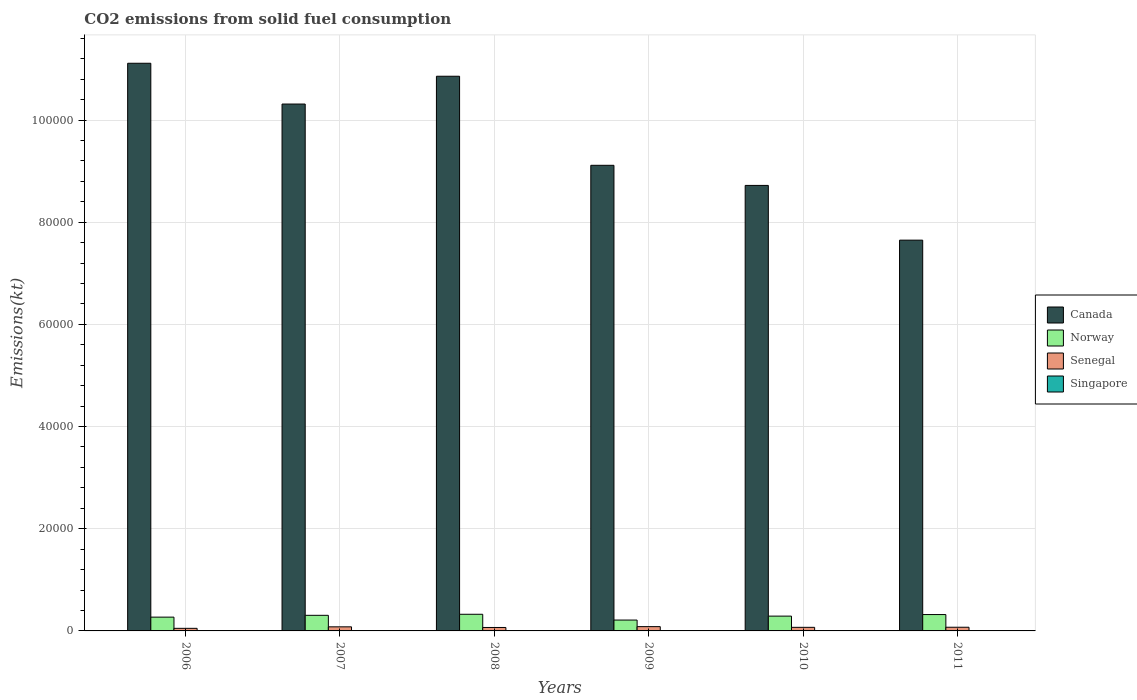How many groups of bars are there?
Offer a terse response. 6. What is the label of the 4th group of bars from the left?
Ensure brevity in your answer.  2009. What is the amount of CO2 emitted in Canada in 2010?
Your answer should be compact. 8.72e+04. Across all years, what is the maximum amount of CO2 emitted in Norway?
Your response must be concise. 3259.96. Across all years, what is the minimum amount of CO2 emitted in Senegal?
Make the answer very short. 506.05. In which year was the amount of CO2 emitted in Canada maximum?
Provide a short and direct response. 2006. In which year was the amount of CO2 emitted in Canada minimum?
Give a very brief answer. 2011. What is the total amount of CO2 emitted in Singapore in the graph?
Your answer should be very brief. 113.68. What is the difference between the amount of CO2 emitted in Norway in 2008 and that in 2010?
Provide a short and direct response. 363.03. What is the difference between the amount of CO2 emitted in Canada in 2007 and the amount of CO2 emitted in Singapore in 2009?
Your response must be concise. 1.03e+05. What is the average amount of CO2 emitted in Singapore per year?
Ensure brevity in your answer.  18.95. In the year 2008, what is the difference between the amount of CO2 emitted in Norway and amount of CO2 emitted in Singapore?
Your response must be concise. 3241.63. In how many years, is the amount of CO2 emitted in Norway greater than 104000 kt?
Your answer should be very brief. 0. What is the ratio of the amount of CO2 emitted in Singapore in 2007 to that in 2011?
Offer a terse response. 1.75. Is the amount of CO2 emitted in Norway in 2007 less than that in 2008?
Your answer should be compact. Yes. What is the difference between the highest and the second highest amount of CO2 emitted in Norway?
Ensure brevity in your answer.  55.01. What is the difference between the highest and the lowest amount of CO2 emitted in Norway?
Ensure brevity in your answer.  1133.1. In how many years, is the amount of CO2 emitted in Singapore greater than the average amount of CO2 emitted in Singapore taken over all years?
Ensure brevity in your answer.  2. What does the 2nd bar from the left in 2008 represents?
Keep it short and to the point. Norway. What does the 1st bar from the right in 2009 represents?
Give a very brief answer. Singapore. Is it the case that in every year, the sum of the amount of CO2 emitted in Senegal and amount of CO2 emitted in Norway is greater than the amount of CO2 emitted in Canada?
Provide a succinct answer. No. How many bars are there?
Ensure brevity in your answer.  24. Are all the bars in the graph horizontal?
Give a very brief answer. No. What is the difference between two consecutive major ticks on the Y-axis?
Offer a very short reply. 2.00e+04. Does the graph contain any zero values?
Make the answer very short. No. Where does the legend appear in the graph?
Provide a short and direct response. Center right. How are the legend labels stacked?
Keep it short and to the point. Vertical. What is the title of the graph?
Your answer should be compact. CO2 emissions from solid fuel consumption. Does "Latvia" appear as one of the legend labels in the graph?
Give a very brief answer. No. What is the label or title of the X-axis?
Make the answer very short. Years. What is the label or title of the Y-axis?
Provide a short and direct response. Emissions(kt). What is the Emissions(kt) in Canada in 2006?
Make the answer very short. 1.11e+05. What is the Emissions(kt) of Norway in 2006?
Provide a succinct answer. 2698.91. What is the Emissions(kt) in Senegal in 2006?
Provide a short and direct response. 506.05. What is the Emissions(kt) of Singapore in 2006?
Provide a succinct answer. 14.67. What is the Emissions(kt) in Canada in 2007?
Make the answer very short. 1.03e+05. What is the Emissions(kt) in Norway in 2007?
Give a very brief answer. 3054.61. What is the Emissions(kt) of Senegal in 2007?
Make the answer very short. 799.41. What is the Emissions(kt) in Singapore in 2007?
Offer a very short reply. 25.67. What is the Emissions(kt) of Canada in 2008?
Provide a succinct answer. 1.09e+05. What is the Emissions(kt) in Norway in 2008?
Your answer should be compact. 3259.96. What is the Emissions(kt) in Senegal in 2008?
Your answer should be compact. 674.73. What is the Emissions(kt) of Singapore in 2008?
Give a very brief answer. 18.34. What is the Emissions(kt) of Canada in 2009?
Ensure brevity in your answer.  9.11e+04. What is the Emissions(kt) in Norway in 2009?
Your answer should be very brief. 2126.86. What is the Emissions(kt) in Senegal in 2009?
Give a very brief answer. 839.74. What is the Emissions(kt) in Singapore in 2009?
Your response must be concise. 14.67. What is the Emissions(kt) of Canada in 2010?
Provide a short and direct response. 8.72e+04. What is the Emissions(kt) of Norway in 2010?
Ensure brevity in your answer.  2896.93. What is the Emissions(kt) in Senegal in 2010?
Your answer should be very brief. 700.4. What is the Emissions(kt) in Singapore in 2010?
Make the answer very short. 25.67. What is the Emissions(kt) in Canada in 2011?
Offer a very short reply. 7.65e+04. What is the Emissions(kt) of Norway in 2011?
Make the answer very short. 3204.96. What is the Emissions(kt) in Senegal in 2011?
Provide a short and direct response. 718.73. What is the Emissions(kt) of Singapore in 2011?
Make the answer very short. 14.67. Across all years, what is the maximum Emissions(kt) of Canada?
Provide a short and direct response. 1.11e+05. Across all years, what is the maximum Emissions(kt) in Norway?
Provide a short and direct response. 3259.96. Across all years, what is the maximum Emissions(kt) in Senegal?
Your answer should be compact. 839.74. Across all years, what is the maximum Emissions(kt) in Singapore?
Make the answer very short. 25.67. Across all years, what is the minimum Emissions(kt) in Canada?
Your response must be concise. 7.65e+04. Across all years, what is the minimum Emissions(kt) of Norway?
Your answer should be very brief. 2126.86. Across all years, what is the minimum Emissions(kt) in Senegal?
Your answer should be very brief. 506.05. Across all years, what is the minimum Emissions(kt) of Singapore?
Give a very brief answer. 14.67. What is the total Emissions(kt) of Canada in the graph?
Make the answer very short. 5.78e+05. What is the total Emissions(kt) of Norway in the graph?
Keep it short and to the point. 1.72e+04. What is the total Emissions(kt) in Senegal in the graph?
Your answer should be very brief. 4239.05. What is the total Emissions(kt) in Singapore in the graph?
Offer a terse response. 113.68. What is the difference between the Emissions(kt) in Canada in 2006 and that in 2007?
Offer a terse response. 7983.06. What is the difference between the Emissions(kt) in Norway in 2006 and that in 2007?
Your answer should be compact. -355.7. What is the difference between the Emissions(kt) of Senegal in 2006 and that in 2007?
Keep it short and to the point. -293.36. What is the difference between the Emissions(kt) of Singapore in 2006 and that in 2007?
Offer a very short reply. -11. What is the difference between the Emissions(kt) of Canada in 2006 and that in 2008?
Provide a short and direct response. 2541.23. What is the difference between the Emissions(kt) in Norway in 2006 and that in 2008?
Make the answer very short. -561.05. What is the difference between the Emissions(kt) of Senegal in 2006 and that in 2008?
Give a very brief answer. -168.68. What is the difference between the Emissions(kt) of Singapore in 2006 and that in 2008?
Offer a terse response. -3.67. What is the difference between the Emissions(kt) of Canada in 2006 and that in 2009?
Ensure brevity in your answer.  2.00e+04. What is the difference between the Emissions(kt) of Norway in 2006 and that in 2009?
Ensure brevity in your answer.  572.05. What is the difference between the Emissions(kt) of Senegal in 2006 and that in 2009?
Your answer should be compact. -333.7. What is the difference between the Emissions(kt) in Singapore in 2006 and that in 2009?
Offer a terse response. 0. What is the difference between the Emissions(kt) in Canada in 2006 and that in 2010?
Provide a succinct answer. 2.39e+04. What is the difference between the Emissions(kt) of Norway in 2006 and that in 2010?
Give a very brief answer. -198.02. What is the difference between the Emissions(kt) in Senegal in 2006 and that in 2010?
Offer a terse response. -194.35. What is the difference between the Emissions(kt) in Singapore in 2006 and that in 2010?
Offer a very short reply. -11. What is the difference between the Emissions(kt) in Canada in 2006 and that in 2011?
Your answer should be compact. 3.46e+04. What is the difference between the Emissions(kt) in Norway in 2006 and that in 2011?
Give a very brief answer. -506.05. What is the difference between the Emissions(kt) of Senegal in 2006 and that in 2011?
Your response must be concise. -212.69. What is the difference between the Emissions(kt) of Singapore in 2006 and that in 2011?
Your answer should be very brief. 0. What is the difference between the Emissions(kt) of Canada in 2007 and that in 2008?
Make the answer very short. -5441.83. What is the difference between the Emissions(kt) in Norway in 2007 and that in 2008?
Offer a very short reply. -205.35. What is the difference between the Emissions(kt) in Senegal in 2007 and that in 2008?
Your answer should be compact. 124.68. What is the difference between the Emissions(kt) in Singapore in 2007 and that in 2008?
Your answer should be very brief. 7.33. What is the difference between the Emissions(kt) of Canada in 2007 and that in 2009?
Provide a succinct answer. 1.20e+04. What is the difference between the Emissions(kt) of Norway in 2007 and that in 2009?
Your response must be concise. 927.75. What is the difference between the Emissions(kt) in Senegal in 2007 and that in 2009?
Ensure brevity in your answer.  -40.34. What is the difference between the Emissions(kt) in Singapore in 2007 and that in 2009?
Your answer should be compact. 11. What is the difference between the Emissions(kt) in Canada in 2007 and that in 2010?
Make the answer very short. 1.59e+04. What is the difference between the Emissions(kt) in Norway in 2007 and that in 2010?
Offer a very short reply. 157.68. What is the difference between the Emissions(kt) in Senegal in 2007 and that in 2010?
Your answer should be very brief. 99.01. What is the difference between the Emissions(kt) in Canada in 2007 and that in 2011?
Keep it short and to the point. 2.66e+04. What is the difference between the Emissions(kt) of Norway in 2007 and that in 2011?
Your answer should be compact. -150.35. What is the difference between the Emissions(kt) in Senegal in 2007 and that in 2011?
Offer a terse response. 80.67. What is the difference between the Emissions(kt) in Singapore in 2007 and that in 2011?
Provide a short and direct response. 11. What is the difference between the Emissions(kt) in Canada in 2008 and that in 2009?
Make the answer very short. 1.74e+04. What is the difference between the Emissions(kt) in Norway in 2008 and that in 2009?
Your answer should be very brief. 1133.1. What is the difference between the Emissions(kt) of Senegal in 2008 and that in 2009?
Keep it short and to the point. -165.01. What is the difference between the Emissions(kt) in Singapore in 2008 and that in 2009?
Give a very brief answer. 3.67. What is the difference between the Emissions(kt) in Canada in 2008 and that in 2010?
Provide a short and direct response. 2.14e+04. What is the difference between the Emissions(kt) of Norway in 2008 and that in 2010?
Ensure brevity in your answer.  363.03. What is the difference between the Emissions(kt) in Senegal in 2008 and that in 2010?
Keep it short and to the point. -25.67. What is the difference between the Emissions(kt) of Singapore in 2008 and that in 2010?
Make the answer very short. -7.33. What is the difference between the Emissions(kt) of Canada in 2008 and that in 2011?
Offer a very short reply. 3.21e+04. What is the difference between the Emissions(kt) in Norway in 2008 and that in 2011?
Give a very brief answer. 55.01. What is the difference between the Emissions(kt) of Senegal in 2008 and that in 2011?
Offer a very short reply. -44. What is the difference between the Emissions(kt) of Singapore in 2008 and that in 2011?
Keep it short and to the point. 3.67. What is the difference between the Emissions(kt) in Canada in 2009 and that in 2010?
Your answer should be compact. 3934.69. What is the difference between the Emissions(kt) in Norway in 2009 and that in 2010?
Your response must be concise. -770.07. What is the difference between the Emissions(kt) of Senegal in 2009 and that in 2010?
Offer a terse response. 139.35. What is the difference between the Emissions(kt) in Singapore in 2009 and that in 2010?
Offer a very short reply. -11. What is the difference between the Emissions(kt) in Canada in 2009 and that in 2011?
Offer a very short reply. 1.46e+04. What is the difference between the Emissions(kt) of Norway in 2009 and that in 2011?
Make the answer very short. -1078.1. What is the difference between the Emissions(kt) in Senegal in 2009 and that in 2011?
Keep it short and to the point. 121.01. What is the difference between the Emissions(kt) of Singapore in 2009 and that in 2011?
Offer a terse response. 0. What is the difference between the Emissions(kt) of Canada in 2010 and that in 2011?
Provide a short and direct response. 1.07e+04. What is the difference between the Emissions(kt) in Norway in 2010 and that in 2011?
Give a very brief answer. -308.03. What is the difference between the Emissions(kt) in Senegal in 2010 and that in 2011?
Provide a succinct answer. -18.34. What is the difference between the Emissions(kt) of Singapore in 2010 and that in 2011?
Offer a terse response. 11. What is the difference between the Emissions(kt) of Canada in 2006 and the Emissions(kt) of Norway in 2007?
Offer a very short reply. 1.08e+05. What is the difference between the Emissions(kt) in Canada in 2006 and the Emissions(kt) in Senegal in 2007?
Offer a terse response. 1.10e+05. What is the difference between the Emissions(kt) in Canada in 2006 and the Emissions(kt) in Singapore in 2007?
Offer a very short reply. 1.11e+05. What is the difference between the Emissions(kt) of Norway in 2006 and the Emissions(kt) of Senegal in 2007?
Provide a succinct answer. 1899.51. What is the difference between the Emissions(kt) of Norway in 2006 and the Emissions(kt) of Singapore in 2007?
Offer a terse response. 2673.24. What is the difference between the Emissions(kt) in Senegal in 2006 and the Emissions(kt) in Singapore in 2007?
Keep it short and to the point. 480.38. What is the difference between the Emissions(kt) in Canada in 2006 and the Emissions(kt) in Norway in 2008?
Keep it short and to the point. 1.08e+05. What is the difference between the Emissions(kt) of Canada in 2006 and the Emissions(kt) of Senegal in 2008?
Keep it short and to the point. 1.10e+05. What is the difference between the Emissions(kt) of Canada in 2006 and the Emissions(kt) of Singapore in 2008?
Offer a very short reply. 1.11e+05. What is the difference between the Emissions(kt) of Norway in 2006 and the Emissions(kt) of Senegal in 2008?
Your answer should be compact. 2024.18. What is the difference between the Emissions(kt) in Norway in 2006 and the Emissions(kt) in Singapore in 2008?
Ensure brevity in your answer.  2680.58. What is the difference between the Emissions(kt) of Senegal in 2006 and the Emissions(kt) of Singapore in 2008?
Your response must be concise. 487.71. What is the difference between the Emissions(kt) in Canada in 2006 and the Emissions(kt) in Norway in 2009?
Provide a short and direct response. 1.09e+05. What is the difference between the Emissions(kt) of Canada in 2006 and the Emissions(kt) of Senegal in 2009?
Your response must be concise. 1.10e+05. What is the difference between the Emissions(kt) in Canada in 2006 and the Emissions(kt) in Singapore in 2009?
Give a very brief answer. 1.11e+05. What is the difference between the Emissions(kt) of Norway in 2006 and the Emissions(kt) of Senegal in 2009?
Offer a very short reply. 1859.17. What is the difference between the Emissions(kt) in Norway in 2006 and the Emissions(kt) in Singapore in 2009?
Your answer should be very brief. 2684.24. What is the difference between the Emissions(kt) of Senegal in 2006 and the Emissions(kt) of Singapore in 2009?
Offer a terse response. 491.38. What is the difference between the Emissions(kt) of Canada in 2006 and the Emissions(kt) of Norway in 2010?
Offer a terse response. 1.08e+05. What is the difference between the Emissions(kt) of Canada in 2006 and the Emissions(kt) of Senegal in 2010?
Ensure brevity in your answer.  1.10e+05. What is the difference between the Emissions(kt) in Canada in 2006 and the Emissions(kt) in Singapore in 2010?
Your response must be concise. 1.11e+05. What is the difference between the Emissions(kt) of Norway in 2006 and the Emissions(kt) of Senegal in 2010?
Make the answer very short. 1998.52. What is the difference between the Emissions(kt) in Norway in 2006 and the Emissions(kt) in Singapore in 2010?
Give a very brief answer. 2673.24. What is the difference between the Emissions(kt) of Senegal in 2006 and the Emissions(kt) of Singapore in 2010?
Your answer should be compact. 480.38. What is the difference between the Emissions(kt) of Canada in 2006 and the Emissions(kt) of Norway in 2011?
Your response must be concise. 1.08e+05. What is the difference between the Emissions(kt) of Canada in 2006 and the Emissions(kt) of Senegal in 2011?
Your answer should be very brief. 1.10e+05. What is the difference between the Emissions(kt) in Canada in 2006 and the Emissions(kt) in Singapore in 2011?
Offer a terse response. 1.11e+05. What is the difference between the Emissions(kt) in Norway in 2006 and the Emissions(kt) in Senegal in 2011?
Give a very brief answer. 1980.18. What is the difference between the Emissions(kt) of Norway in 2006 and the Emissions(kt) of Singapore in 2011?
Keep it short and to the point. 2684.24. What is the difference between the Emissions(kt) of Senegal in 2006 and the Emissions(kt) of Singapore in 2011?
Provide a succinct answer. 491.38. What is the difference between the Emissions(kt) in Canada in 2007 and the Emissions(kt) in Norway in 2008?
Your answer should be compact. 9.99e+04. What is the difference between the Emissions(kt) of Canada in 2007 and the Emissions(kt) of Senegal in 2008?
Your answer should be very brief. 1.02e+05. What is the difference between the Emissions(kt) in Canada in 2007 and the Emissions(kt) in Singapore in 2008?
Provide a succinct answer. 1.03e+05. What is the difference between the Emissions(kt) of Norway in 2007 and the Emissions(kt) of Senegal in 2008?
Provide a succinct answer. 2379.88. What is the difference between the Emissions(kt) of Norway in 2007 and the Emissions(kt) of Singapore in 2008?
Your answer should be very brief. 3036.28. What is the difference between the Emissions(kt) of Senegal in 2007 and the Emissions(kt) of Singapore in 2008?
Give a very brief answer. 781.07. What is the difference between the Emissions(kt) in Canada in 2007 and the Emissions(kt) in Norway in 2009?
Provide a succinct answer. 1.01e+05. What is the difference between the Emissions(kt) in Canada in 2007 and the Emissions(kt) in Senegal in 2009?
Provide a succinct answer. 1.02e+05. What is the difference between the Emissions(kt) in Canada in 2007 and the Emissions(kt) in Singapore in 2009?
Keep it short and to the point. 1.03e+05. What is the difference between the Emissions(kt) of Norway in 2007 and the Emissions(kt) of Senegal in 2009?
Offer a terse response. 2214.87. What is the difference between the Emissions(kt) of Norway in 2007 and the Emissions(kt) of Singapore in 2009?
Offer a terse response. 3039.94. What is the difference between the Emissions(kt) in Senegal in 2007 and the Emissions(kt) in Singapore in 2009?
Offer a very short reply. 784.74. What is the difference between the Emissions(kt) in Canada in 2007 and the Emissions(kt) in Norway in 2010?
Provide a succinct answer. 1.00e+05. What is the difference between the Emissions(kt) in Canada in 2007 and the Emissions(kt) in Senegal in 2010?
Ensure brevity in your answer.  1.02e+05. What is the difference between the Emissions(kt) of Canada in 2007 and the Emissions(kt) of Singapore in 2010?
Your answer should be very brief. 1.03e+05. What is the difference between the Emissions(kt) of Norway in 2007 and the Emissions(kt) of Senegal in 2010?
Provide a succinct answer. 2354.21. What is the difference between the Emissions(kt) in Norway in 2007 and the Emissions(kt) in Singapore in 2010?
Provide a short and direct response. 3028.94. What is the difference between the Emissions(kt) in Senegal in 2007 and the Emissions(kt) in Singapore in 2010?
Your answer should be very brief. 773.74. What is the difference between the Emissions(kt) in Canada in 2007 and the Emissions(kt) in Norway in 2011?
Your response must be concise. 9.99e+04. What is the difference between the Emissions(kt) in Canada in 2007 and the Emissions(kt) in Senegal in 2011?
Your answer should be very brief. 1.02e+05. What is the difference between the Emissions(kt) in Canada in 2007 and the Emissions(kt) in Singapore in 2011?
Provide a short and direct response. 1.03e+05. What is the difference between the Emissions(kt) in Norway in 2007 and the Emissions(kt) in Senegal in 2011?
Provide a short and direct response. 2335.88. What is the difference between the Emissions(kt) in Norway in 2007 and the Emissions(kt) in Singapore in 2011?
Your answer should be very brief. 3039.94. What is the difference between the Emissions(kt) of Senegal in 2007 and the Emissions(kt) of Singapore in 2011?
Your answer should be very brief. 784.74. What is the difference between the Emissions(kt) in Canada in 2008 and the Emissions(kt) in Norway in 2009?
Offer a terse response. 1.06e+05. What is the difference between the Emissions(kt) of Canada in 2008 and the Emissions(kt) of Senegal in 2009?
Give a very brief answer. 1.08e+05. What is the difference between the Emissions(kt) in Canada in 2008 and the Emissions(kt) in Singapore in 2009?
Your answer should be very brief. 1.09e+05. What is the difference between the Emissions(kt) in Norway in 2008 and the Emissions(kt) in Senegal in 2009?
Provide a short and direct response. 2420.22. What is the difference between the Emissions(kt) in Norway in 2008 and the Emissions(kt) in Singapore in 2009?
Your answer should be compact. 3245.3. What is the difference between the Emissions(kt) in Senegal in 2008 and the Emissions(kt) in Singapore in 2009?
Provide a succinct answer. 660.06. What is the difference between the Emissions(kt) in Canada in 2008 and the Emissions(kt) in Norway in 2010?
Your answer should be compact. 1.06e+05. What is the difference between the Emissions(kt) of Canada in 2008 and the Emissions(kt) of Senegal in 2010?
Offer a very short reply. 1.08e+05. What is the difference between the Emissions(kt) in Canada in 2008 and the Emissions(kt) in Singapore in 2010?
Provide a succinct answer. 1.09e+05. What is the difference between the Emissions(kt) in Norway in 2008 and the Emissions(kt) in Senegal in 2010?
Provide a succinct answer. 2559.57. What is the difference between the Emissions(kt) of Norway in 2008 and the Emissions(kt) of Singapore in 2010?
Ensure brevity in your answer.  3234.29. What is the difference between the Emissions(kt) of Senegal in 2008 and the Emissions(kt) of Singapore in 2010?
Provide a short and direct response. 649.06. What is the difference between the Emissions(kt) in Canada in 2008 and the Emissions(kt) in Norway in 2011?
Give a very brief answer. 1.05e+05. What is the difference between the Emissions(kt) of Canada in 2008 and the Emissions(kt) of Senegal in 2011?
Offer a very short reply. 1.08e+05. What is the difference between the Emissions(kt) in Canada in 2008 and the Emissions(kt) in Singapore in 2011?
Provide a succinct answer. 1.09e+05. What is the difference between the Emissions(kt) in Norway in 2008 and the Emissions(kt) in Senegal in 2011?
Offer a very short reply. 2541.23. What is the difference between the Emissions(kt) of Norway in 2008 and the Emissions(kt) of Singapore in 2011?
Offer a very short reply. 3245.3. What is the difference between the Emissions(kt) of Senegal in 2008 and the Emissions(kt) of Singapore in 2011?
Your answer should be compact. 660.06. What is the difference between the Emissions(kt) of Canada in 2009 and the Emissions(kt) of Norway in 2010?
Ensure brevity in your answer.  8.82e+04. What is the difference between the Emissions(kt) in Canada in 2009 and the Emissions(kt) in Senegal in 2010?
Provide a succinct answer. 9.04e+04. What is the difference between the Emissions(kt) in Canada in 2009 and the Emissions(kt) in Singapore in 2010?
Give a very brief answer. 9.11e+04. What is the difference between the Emissions(kt) in Norway in 2009 and the Emissions(kt) in Senegal in 2010?
Keep it short and to the point. 1426.46. What is the difference between the Emissions(kt) in Norway in 2009 and the Emissions(kt) in Singapore in 2010?
Provide a succinct answer. 2101.19. What is the difference between the Emissions(kt) of Senegal in 2009 and the Emissions(kt) of Singapore in 2010?
Ensure brevity in your answer.  814.07. What is the difference between the Emissions(kt) of Canada in 2009 and the Emissions(kt) of Norway in 2011?
Offer a terse response. 8.79e+04. What is the difference between the Emissions(kt) of Canada in 2009 and the Emissions(kt) of Senegal in 2011?
Provide a short and direct response. 9.04e+04. What is the difference between the Emissions(kt) in Canada in 2009 and the Emissions(kt) in Singapore in 2011?
Keep it short and to the point. 9.11e+04. What is the difference between the Emissions(kt) in Norway in 2009 and the Emissions(kt) in Senegal in 2011?
Offer a terse response. 1408.13. What is the difference between the Emissions(kt) in Norway in 2009 and the Emissions(kt) in Singapore in 2011?
Ensure brevity in your answer.  2112.19. What is the difference between the Emissions(kt) in Senegal in 2009 and the Emissions(kt) in Singapore in 2011?
Offer a terse response. 825.08. What is the difference between the Emissions(kt) of Canada in 2010 and the Emissions(kt) of Norway in 2011?
Ensure brevity in your answer.  8.40e+04. What is the difference between the Emissions(kt) in Canada in 2010 and the Emissions(kt) in Senegal in 2011?
Your answer should be compact. 8.65e+04. What is the difference between the Emissions(kt) in Canada in 2010 and the Emissions(kt) in Singapore in 2011?
Your response must be concise. 8.72e+04. What is the difference between the Emissions(kt) of Norway in 2010 and the Emissions(kt) of Senegal in 2011?
Provide a short and direct response. 2178.2. What is the difference between the Emissions(kt) of Norway in 2010 and the Emissions(kt) of Singapore in 2011?
Provide a succinct answer. 2882.26. What is the difference between the Emissions(kt) of Senegal in 2010 and the Emissions(kt) of Singapore in 2011?
Your answer should be compact. 685.73. What is the average Emissions(kt) in Canada per year?
Your response must be concise. 9.63e+04. What is the average Emissions(kt) of Norway per year?
Offer a terse response. 2873.71. What is the average Emissions(kt) in Senegal per year?
Your answer should be compact. 706.51. What is the average Emissions(kt) in Singapore per year?
Keep it short and to the point. 18.95. In the year 2006, what is the difference between the Emissions(kt) in Canada and Emissions(kt) in Norway?
Offer a terse response. 1.08e+05. In the year 2006, what is the difference between the Emissions(kt) in Canada and Emissions(kt) in Senegal?
Make the answer very short. 1.11e+05. In the year 2006, what is the difference between the Emissions(kt) in Canada and Emissions(kt) in Singapore?
Your response must be concise. 1.11e+05. In the year 2006, what is the difference between the Emissions(kt) of Norway and Emissions(kt) of Senegal?
Your response must be concise. 2192.87. In the year 2006, what is the difference between the Emissions(kt) of Norway and Emissions(kt) of Singapore?
Give a very brief answer. 2684.24. In the year 2006, what is the difference between the Emissions(kt) in Senegal and Emissions(kt) in Singapore?
Provide a short and direct response. 491.38. In the year 2007, what is the difference between the Emissions(kt) of Canada and Emissions(kt) of Norway?
Your answer should be very brief. 1.00e+05. In the year 2007, what is the difference between the Emissions(kt) in Canada and Emissions(kt) in Senegal?
Offer a very short reply. 1.02e+05. In the year 2007, what is the difference between the Emissions(kt) in Canada and Emissions(kt) in Singapore?
Provide a succinct answer. 1.03e+05. In the year 2007, what is the difference between the Emissions(kt) in Norway and Emissions(kt) in Senegal?
Your response must be concise. 2255.2. In the year 2007, what is the difference between the Emissions(kt) of Norway and Emissions(kt) of Singapore?
Give a very brief answer. 3028.94. In the year 2007, what is the difference between the Emissions(kt) of Senegal and Emissions(kt) of Singapore?
Give a very brief answer. 773.74. In the year 2008, what is the difference between the Emissions(kt) of Canada and Emissions(kt) of Norway?
Give a very brief answer. 1.05e+05. In the year 2008, what is the difference between the Emissions(kt) in Canada and Emissions(kt) in Senegal?
Ensure brevity in your answer.  1.08e+05. In the year 2008, what is the difference between the Emissions(kt) of Canada and Emissions(kt) of Singapore?
Make the answer very short. 1.09e+05. In the year 2008, what is the difference between the Emissions(kt) of Norway and Emissions(kt) of Senegal?
Your answer should be compact. 2585.24. In the year 2008, what is the difference between the Emissions(kt) of Norway and Emissions(kt) of Singapore?
Make the answer very short. 3241.63. In the year 2008, what is the difference between the Emissions(kt) in Senegal and Emissions(kt) in Singapore?
Offer a very short reply. 656.39. In the year 2009, what is the difference between the Emissions(kt) in Canada and Emissions(kt) in Norway?
Your response must be concise. 8.90e+04. In the year 2009, what is the difference between the Emissions(kt) in Canada and Emissions(kt) in Senegal?
Keep it short and to the point. 9.03e+04. In the year 2009, what is the difference between the Emissions(kt) of Canada and Emissions(kt) of Singapore?
Offer a very short reply. 9.11e+04. In the year 2009, what is the difference between the Emissions(kt) in Norway and Emissions(kt) in Senegal?
Ensure brevity in your answer.  1287.12. In the year 2009, what is the difference between the Emissions(kt) of Norway and Emissions(kt) of Singapore?
Ensure brevity in your answer.  2112.19. In the year 2009, what is the difference between the Emissions(kt) of Senegal and Emissions(kt) of Singapore?
Offer a very short reply. 825.08. In the year 2010, what is the difference between the Emissions(kt) of Canada and Emissions(kt) of Norway?
Your answer should be compact. 8.43e+04. In the year 2010, what is the difference between the Emissions(kt) in Canada and Emissions(kt) in Senegal?
Offer a very short reply. 8.65e+04. In the year 2010, what is the difference between the Emissions(kt) in Canada and Emissions(kt) in Singapore?
Offer a terse response. 8.72e+04. In the year 2010, what is the difference between the Emissions(kt) in Norway and Emissions(kt) in Senegal?
Make the answer very short. 2196.53. In the year 2010, what is the difference between the Emissions(kt) in Norway and Emissions(kt) in Singapore?
Provide a short and direct response. 2871.26. In the year 2010, what is the difference between the Emissions(kt) of Senegal and Emissions(kt) of Singapore?
Offer a terse response. 674.73. In the year 2011, what is the difference between the Emissions(kt) in Canada and Emissions(kt) in Norway?
Your answer should be very brief. 7.33e+04. In the year 2011, what is the difference between the Emissions(kt) in Canada and Emissions(kt) in Senegal?
Give a very brief answer. 7.58e+04. In the year 2011, what is the difference between the Emissions(kt) of Canada and Emissions(kt) of Singapore?
Your response must be concise. 7.65e+04. In the year 2011, what is the difference between the Emissions(kt) of Norway and Emissions(kt) of Senegal?
Ensure brevity in your answer.  2486.23. In the year 2011, what is the difference between the Emissions(kt) of Norway and Emissions(kt) of Singapore?
Your response must be concise. 3190.29. In the year 2011, what is the difference between the Emissions(kt) of Senegal and Emissions(kt) of Singapore?
Provide a succinct answer. 704.06. What is the ratio of the Emissions(kt) in Canada in 2006 to that in 2007?
Give a very brief answer. 1.08. What is the ratio of the Emissions(kt) in Norway in 2006 to that in 2007?
Your answer should be very brief. 0.88. What is the ratio of the Emissions(kt) of Senegal in 2006 to that in 2007?
Provide a short and direct response. 0.63. What is the ratio of the Emissions(kt) in Canada in 2006 to that in 2008?
Offer a very short reply. 1.02. What is the ratio of the Emissions(kt) of Norway in 2006 to that in 2008?
Your response must be concise. 0.83. What is the ratio of the Emissions(kt) in Senegal in 2006 to that in 2008?
Give a very brief answer. 0.75. What is the ratio of the Emissions(kt) of Singapore in 2006 to that in 2008?
Provide a short and direct response. 0.8. What is the ratio of the Emissions(kt) of Canada in 2006 to that in 2009?
Give a very brief answer. 1.22. What is the ratio of the Emissions(kt) of Norway in 2006 to that in 2009?
Ensure brevity in your answer.  1.27. What is the ratio of the Emissions(kt) in Senegal in 2006 to that in 2009?
Provide a succinct answer. 0.6. What is the ratio of the Emissions(kt) in Singapore in 2006 to that in 2009?
Keep it short and to the point. 1. What is the ratio of the Emissions(kt) of Canada in 2006 to that in 2010?
Make the answer very short. 1.27. What is the ratio of the Emissions(kt) in Norway in 2006 to that in 2010?
Provide a succinct answer. 0.93. What is the ratio of the Emissions(kt) in Senegal in 2006 to that in 2010?
Your answer should be very brief. 0.72. What is the ratio of the Emissions(kt) of Singapore in 2006 to that in 2010?
Provide a succinct answer. 0.57. What is the ratio of the Emissions(kt) of Canada in 2006 to that in 2011?
Make the answer very short. 1.45. What is the ratio of the Emissions(kt) in Norway in 2006 to that in 2011?
Offer a terse response. 0.84. What is the ratio of the Emissions(kt) of Senegal in 2006 to that in 2011?
Your answer should be very brief. 0.7. What is the ratio of the Emissions(kt) of Singapore in 2006 to that in 2011?
Make the answer very short. 1. What is the ratio of the Emissions(kt) in Canada in 2007 to that in 2008?
Ensure brevity in your answer.  0.95. What is the ratio of the Emissions(kt) of Norway in 2007 to that in 2008?
Give a very brief answer. 0.94. What is the ratio of the Emissions(kt) in Senegal in 2007 to that in 2008?
Offer a terse response. 1.18. What is the ratio of the Emissions(kt) in Singapore in 2007 to that in 2008?
Give a very brief answer. 1.4. What is the ratio of the Emissions(kt) in Canada in 2007 to that in 2009?
Your answer should be very brief. 1.13. What is the ratio of the Emissions(kt) in Norway in 2007 to that in 2009?
Give a very brief answer. 1.44. What is the ratio of the Emissions(kt) of Senegal in 2007 to that in 2009?
Offer a terse response. 0.95. What is the ratio of the Emissions(kt) of Singapore in 2007 to that in 2009?
Provide a succinct answer. 1.75. What is the ratio of the Emissions(kt) of Canada in 2007 to that in 2010?
Provide a succinct answer. 1.18. What is the ratio of the Emissions(kt) in Norway in 2007 to that in 2010?
Your answer should be compact. 1.05. What is the ratio of the Emissions(kt) in Senegal in 2007 to that in 2010?
Give a very brief answer. 1.14. What is the ratio of the Emissions(kt) in Singapore in 2007 to that in 2010?
Make the answer very short. 1. What is the ratio of the Emissions(kt) of Canada in 2007 to that in 2011?
Your response must be concise. 1.35. What is the ratio of the Emissions(kt) of Norway in 2007 to that in 2011?
Ensure brevity in your answer.  0.95. What is the ratio of the Emissions(kt) of Senegal in 2007 to that in 2011?
Your answer should be compact. 1.11. What is the ratio of the Emissions(kt) in Singapore in 2007 to that in 2011?
Your response must be concise. 1.75. What is the ratio of the Emissions(kt) of Canada in 2008 to that in 2009?
Offer a terse response. 1.19. What is the ratio of the Emissions(kt) in Norway in 2008 to that in 2009?
Your answer should be very brief. 1.53. What is the ratio of the Emissions(kt) of Senegal in 2008 to that in 2009?
Your answer should be very brief. 0.8. What is the ratio of the Emissions(kt) in Singapore in 2008 to that in 2009?
Provide a short and direct response. 1.25. What is the ratio of the Emissions(kt) in Canada in 2008 to that in 2010?
Your answer should be compact. 1.25. What is the ratio of the Emissions(kt) in Norway in 2008 to that in 2010?
Ensure brevity in your answer.  1.13. What is the ratio of the Emissions(kt) of Senegal in 2008 to that in 2010?
Offer a very short reply. 0.96. What is the ratio of the Emissions(kt) of Singapore in 2008 to that in 2010?
Your response must be concise. 0.71. What is the ratio of the Emissions(kt) of Canada in 2008 to that in 2011?
Give a very brief answer. 1.42. What is the ratio of the Emissions(kt) of Norway in 2008 to that in 2011?
Your response must be concise. 1.02. What is the ratio of the Emissions(kt) in Senegal in 2008 to that in 2011?
Ensure brevity in your answer.  0.94. What is the ratio of the Emissions(kt) in Canada in 2009 to that in 2010?
Make the answer very short. 1.05. What is the ratio of the Emissions(kt) in Norway in 2009 to that in 2010?
Your response must be concise. 0.73. What is the ratio of the Emissions(kt) of Senegal in 2009 to that in 2010?
Your response must be concise. 1.2. What is the ratio of the Emissions(kt) in Singapore in 2009 to that in 2010?
Your answer should be very brief. 0.57. What is the ratio of the Emissions(kt) of Canada in 2009 to that in 2011?
Your response must be concise. 1.19. What is the ratio of the Emissions(kt) of Norway in 2009 to that in 2011?
Provide a short and direct response. 0.66. What is the ratio of the Emissions(kt) of Senegal in 2009 to that in 2011?
Keep it short and to the point. 1.17. What is the ratio of the Emissions(kt) in Canada in 2010 to that in 2011?
Keep it short and to the point. 1.14. What is the ratio of the Emissions(kt) of Norway in 2010 to that in 2011?
Ensure brevity in your answer.  0.9. What is the ratio of the Emissions(kt) in Senegal in 2010 to that in 2011?
Offer a very short reply. 0.97. What is the ratio of the Emissions(kt) of Singapore in 2010 to that in 2011?
Provide a succinct answer. 1.75. What is the difference between the highest and the second highest Emissions(kt) of Canada?
Offer a very short reply. 2541.23. What is the difference between the highest and the second highest Emissions(kt) of Norway?
Offer a terse response. 55.01. What is the difference between the highest and the second highest Emissions(kt) of Senegal?
Ensure brevity in your answer.  40.34. What is the difference between the highest and the lowest Emissions(kt) of Canada?
Your response must be concise. 3.46e+04. What is the difference between the highest and the lowest Emissions(kt) in Norway?
Keep it short and to the point. 1133.1. What is the difference between the highest and the lowest Emissions(kt) of Senegal?
Offer a terse response. 333.7. What is the difference between the highest and the lowest Emissions(kt) of Singapore?
Make the answer very short. 11. 